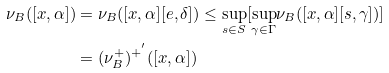Convert formula to latex. <formula><loc_0><loc_0><loc_500><loc_500>\nu _ { B } ( [ x , \alpha ] ) & = \nu _ { B } ( [ x , \alpha ] [ e , \delta ] ) \leq \underset { s \in S } { \sup } [ \underset { \gamma \in \Gamma } { \sup } \nu _ { B } ( [ x , \alpha ] [ s , \gamma ] ) ] \\ & = ( \nu _ { B } ^ { + } ) ^ { + ^ { ^ { \prime } } } ( [ x , \alpha ] )</formula> 